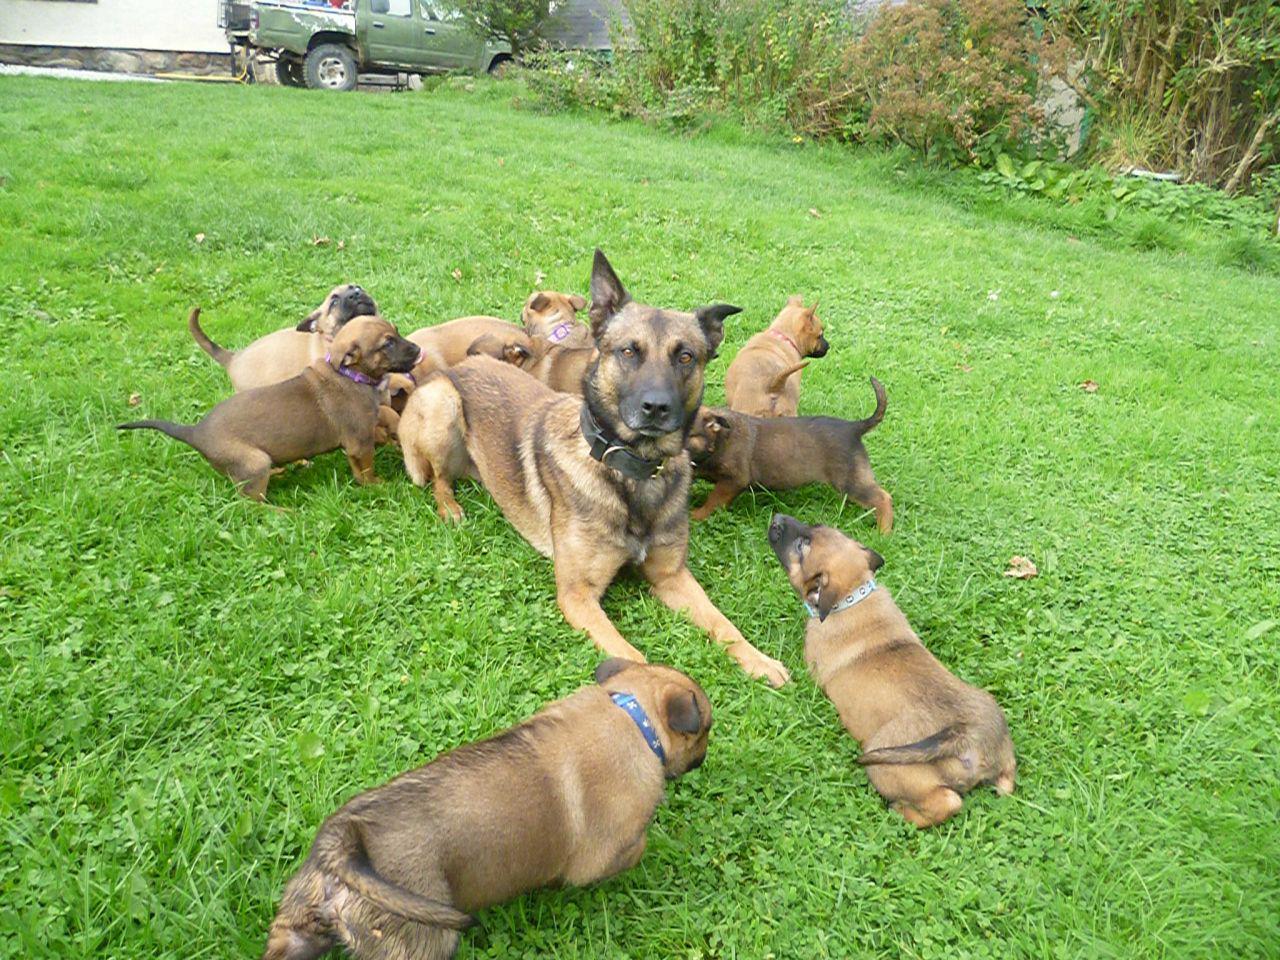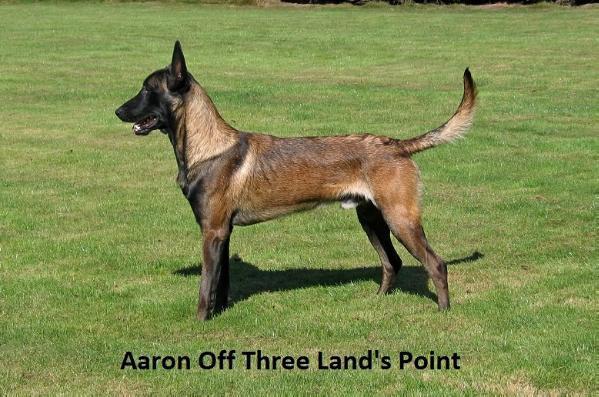The first image is the image on the left, the second image is the image on the right. For the images shown, is this caption "There is exactly three dogs in the left image." true? Answer yes or no. No. The first image is the image on the left, the second image is the image on the right. Given the left and right images, does the statement "Every photograph shows exactly three German Shepard dogs photographed outside, with at least two dogs on the left hand side sticking their tongues out." hold true? Answer yes or no. No. 